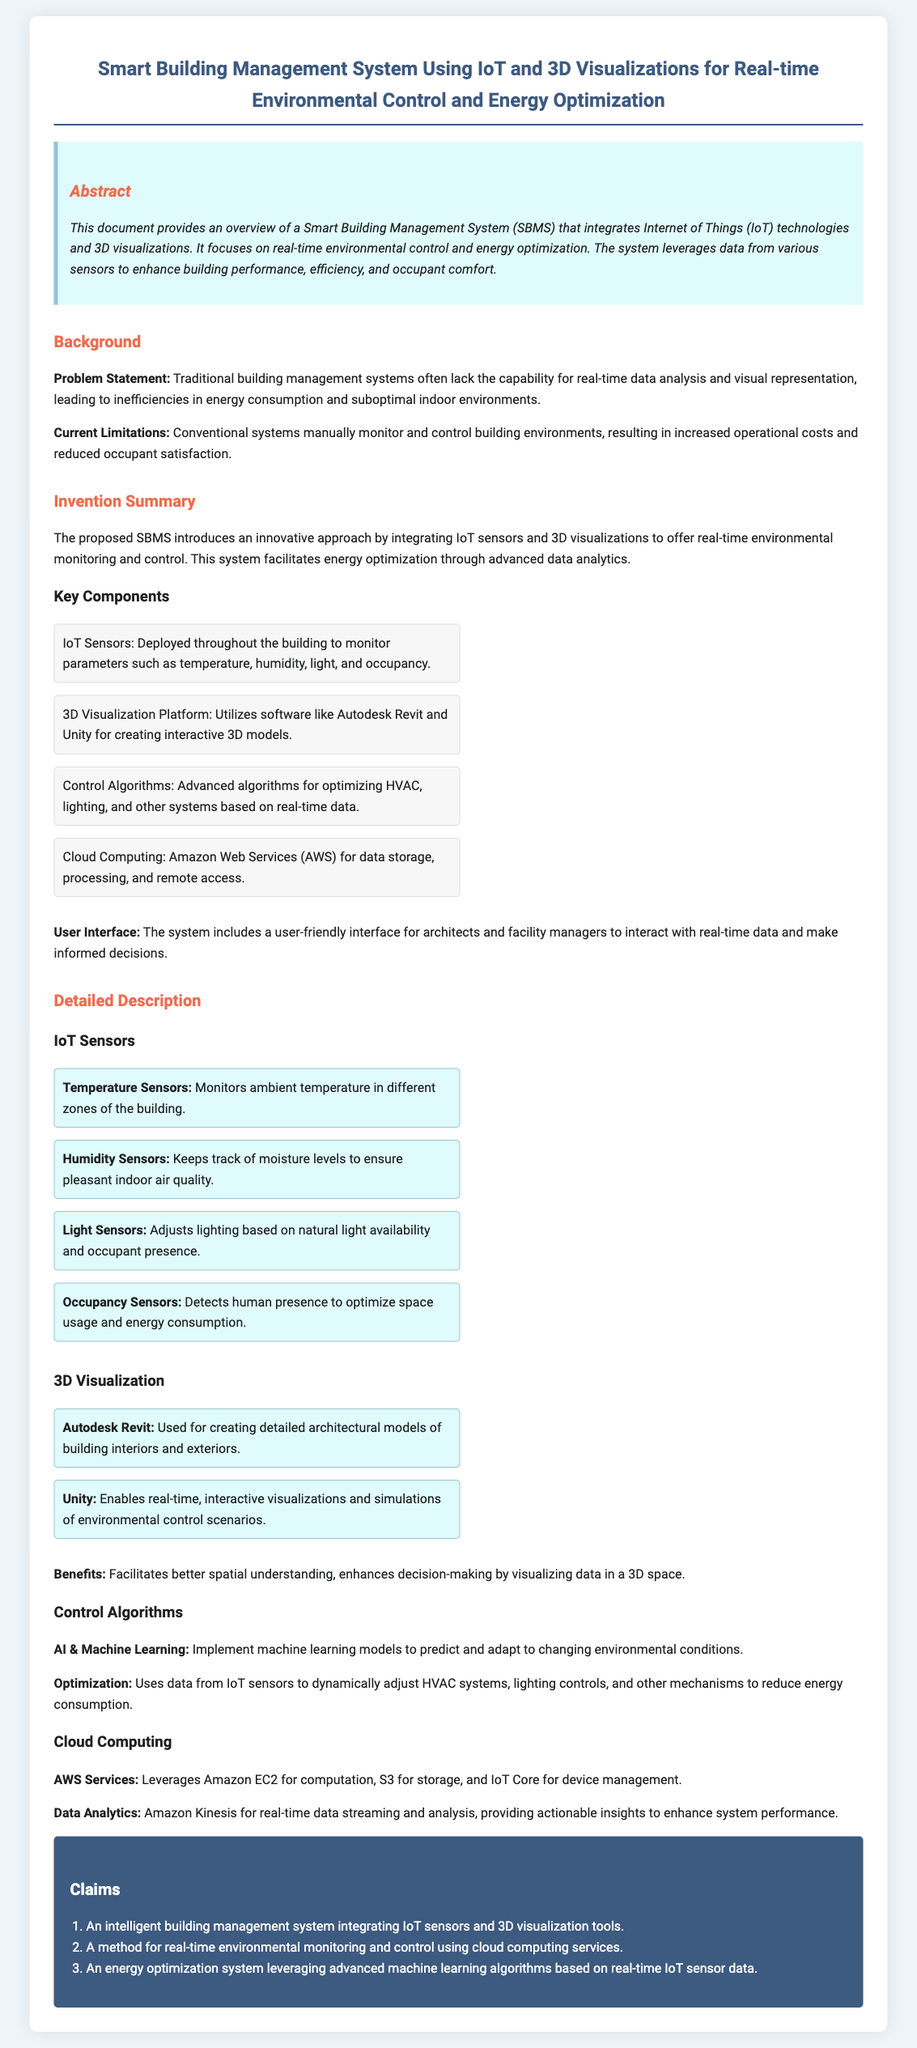What is the title of the patent application? The title of the patent application is explicitly mentioned at the top of the document.
Answer: Smart Building Management System Using IoT and 3D Visualizations for Real-time Environmental Control and Energy Optimization What is the main focus of the Smart Building Management System? The document states that the system focuses on enhancing building performance and efficiency, which can be gathered from the abstract.
Answer: Real-time environmental control and energy optimization What current limitation does the SBMS address? The limitations of conventional systems, as stated in the background section, highlight inefficiencies and costs.
Answer: Increased operational costs and reduced occupant satisfaction Which software is mentioned for creating 3D models? The specific software used for creating interactive 3D models is listed in the key components section.
Answer: Autodesk Revit and Unity What type of sensors are used in the SBMS? The document lists several types of sensors as key components used throughout the building for monitoring various parameters.
Answer: IoT Sensors What cloud service is utilized for data storage in the proposed system? The cloud service used for storage is mentioned in the cloud computing section.
Answer: Amazon Web Services (AWS) What is the role of AI in the Smart Building Management System? AI’s involvement is described in the control algorithms section, detailing its predictive capabilities.
Answer: Predict and adapt to changing environmental conditions How many claims are there in the patent application? The number of claims is presented in the claims section, describing the innovative aspects of the system.
Answer: Three claims What is the benefit of 3D visualization mentioned in the document? The benefit is specifically noted in the detailed description about enhancing decision-making.
Answer: Better spatial understanding and enhances decision-making 